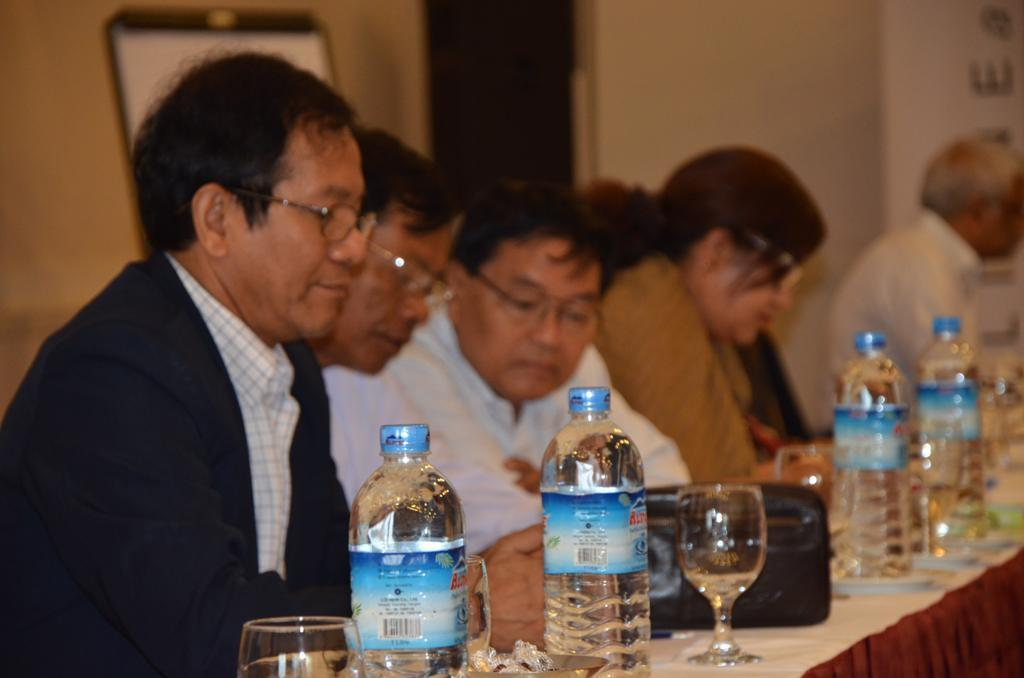How many people are in the image? There is a group of people in the image. What are the people doing in the image? The people are sitting at a table. What objects can be seen on the table in the image? There are bottles and water glasses on the table. How many passengers are visible in the image? There is no reference to passengers in the image; it features a group of people sitting at a table. 